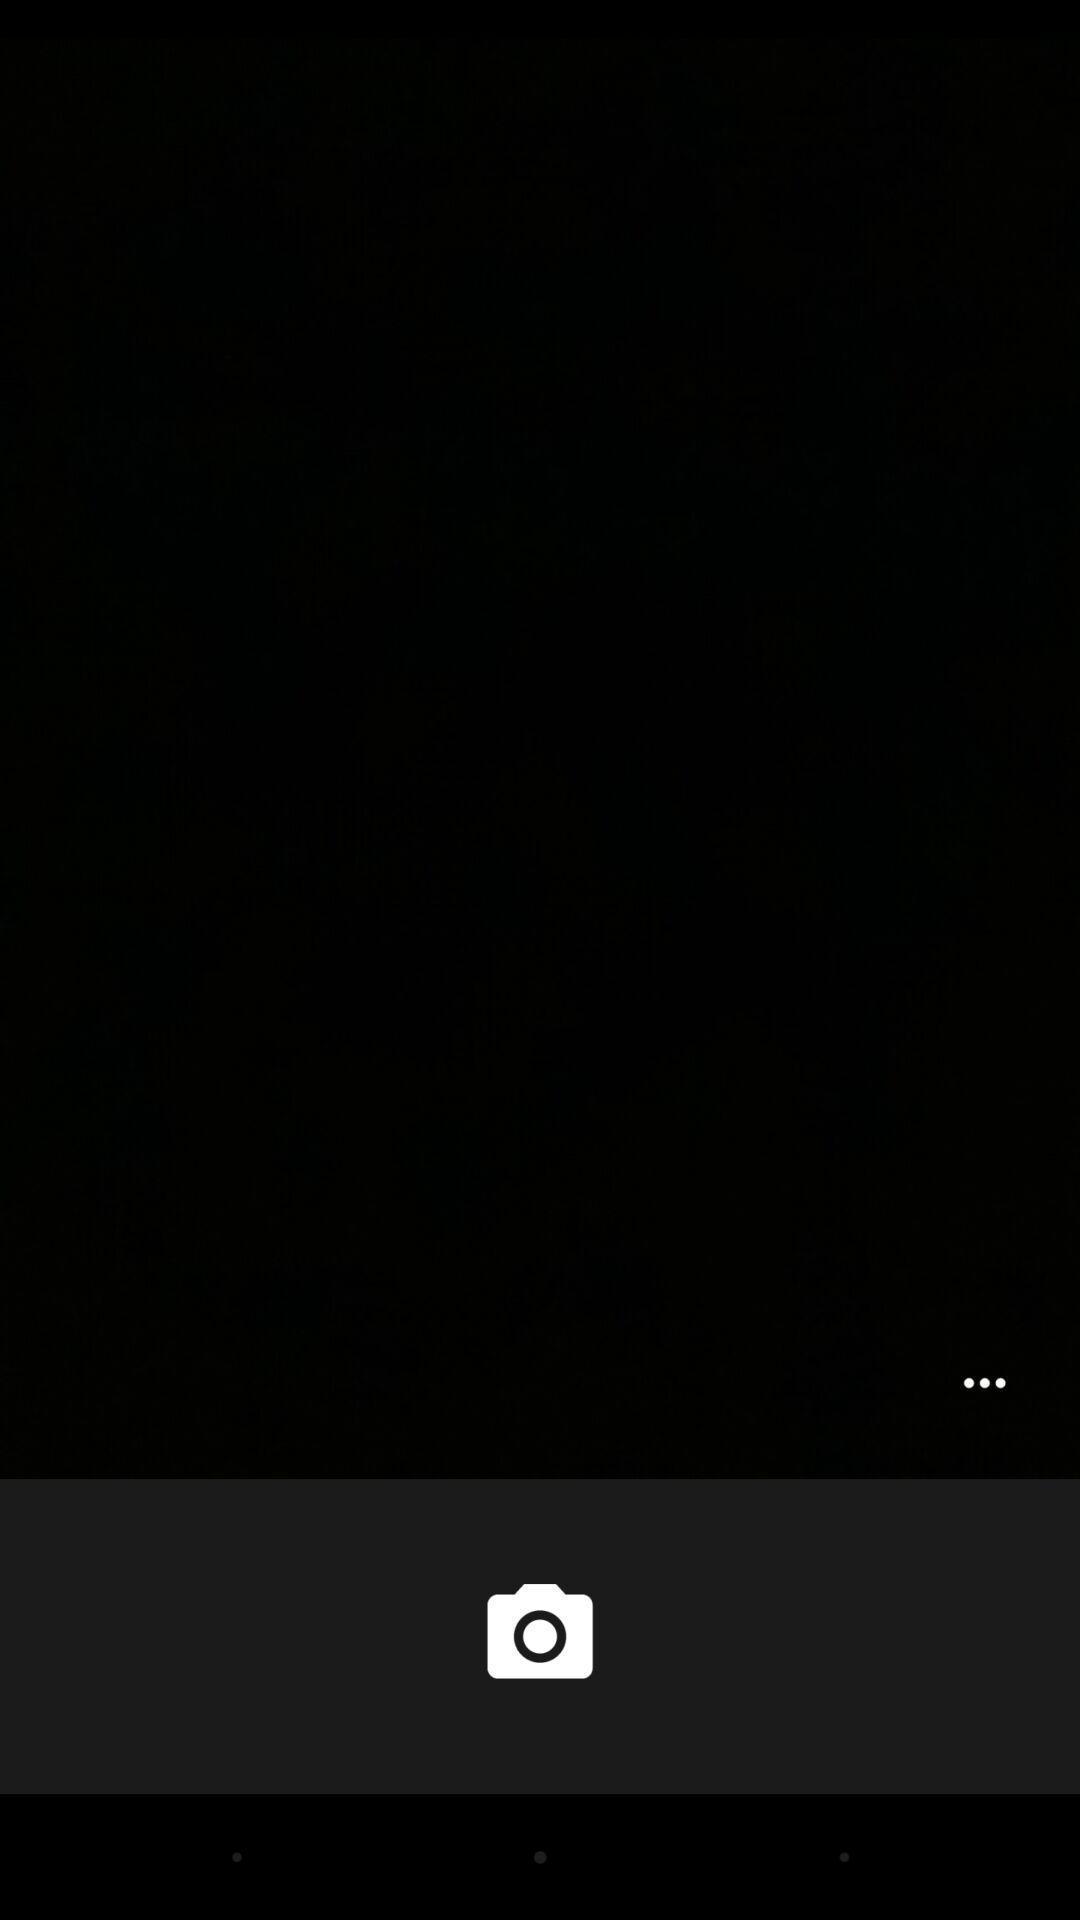Please provide a description for this image. Screen showing the blank page of camera app. 